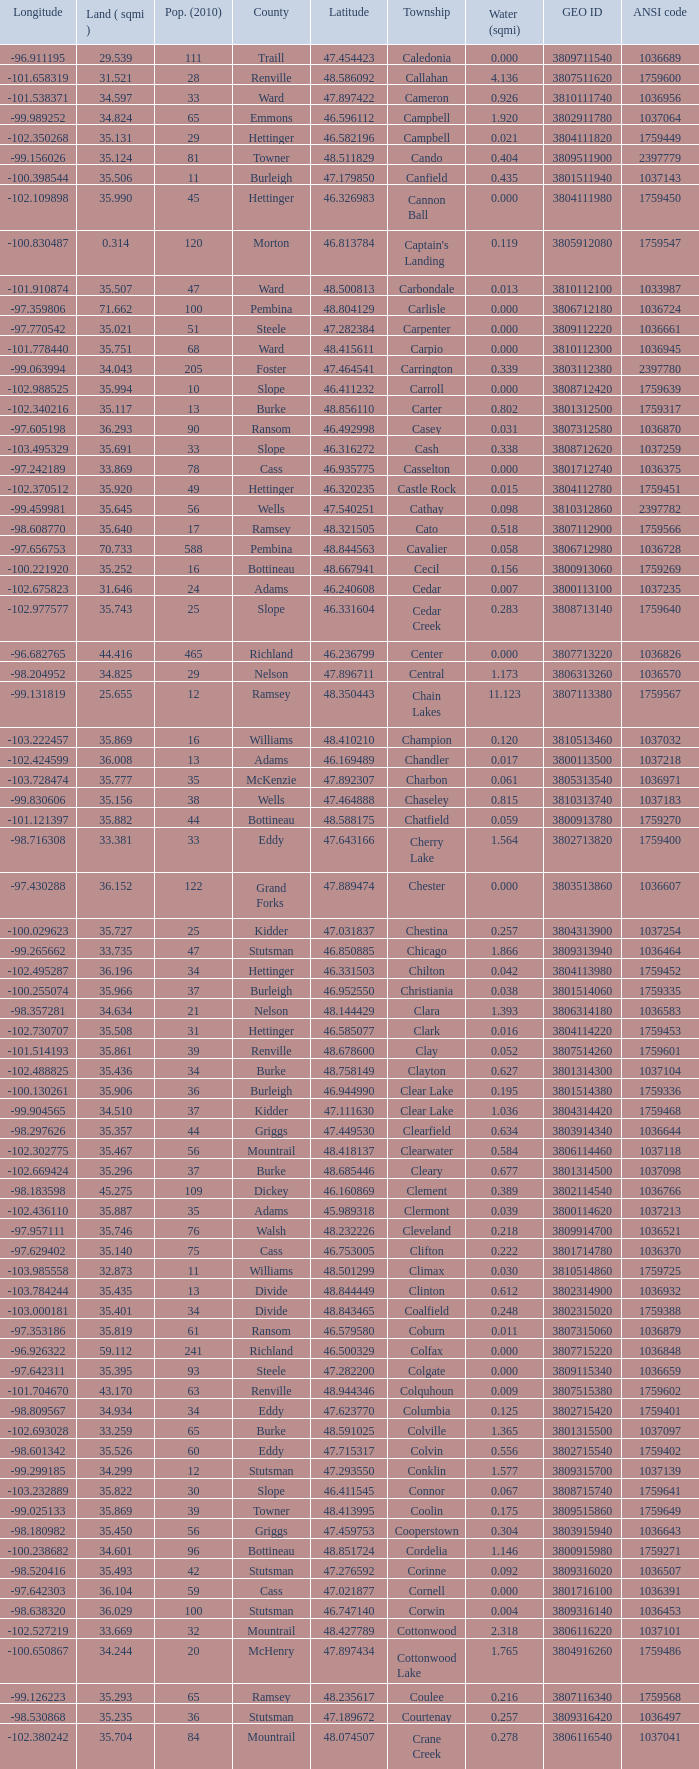What was the land area in sqmi that has a latitude of 48.763937? 35.898. 